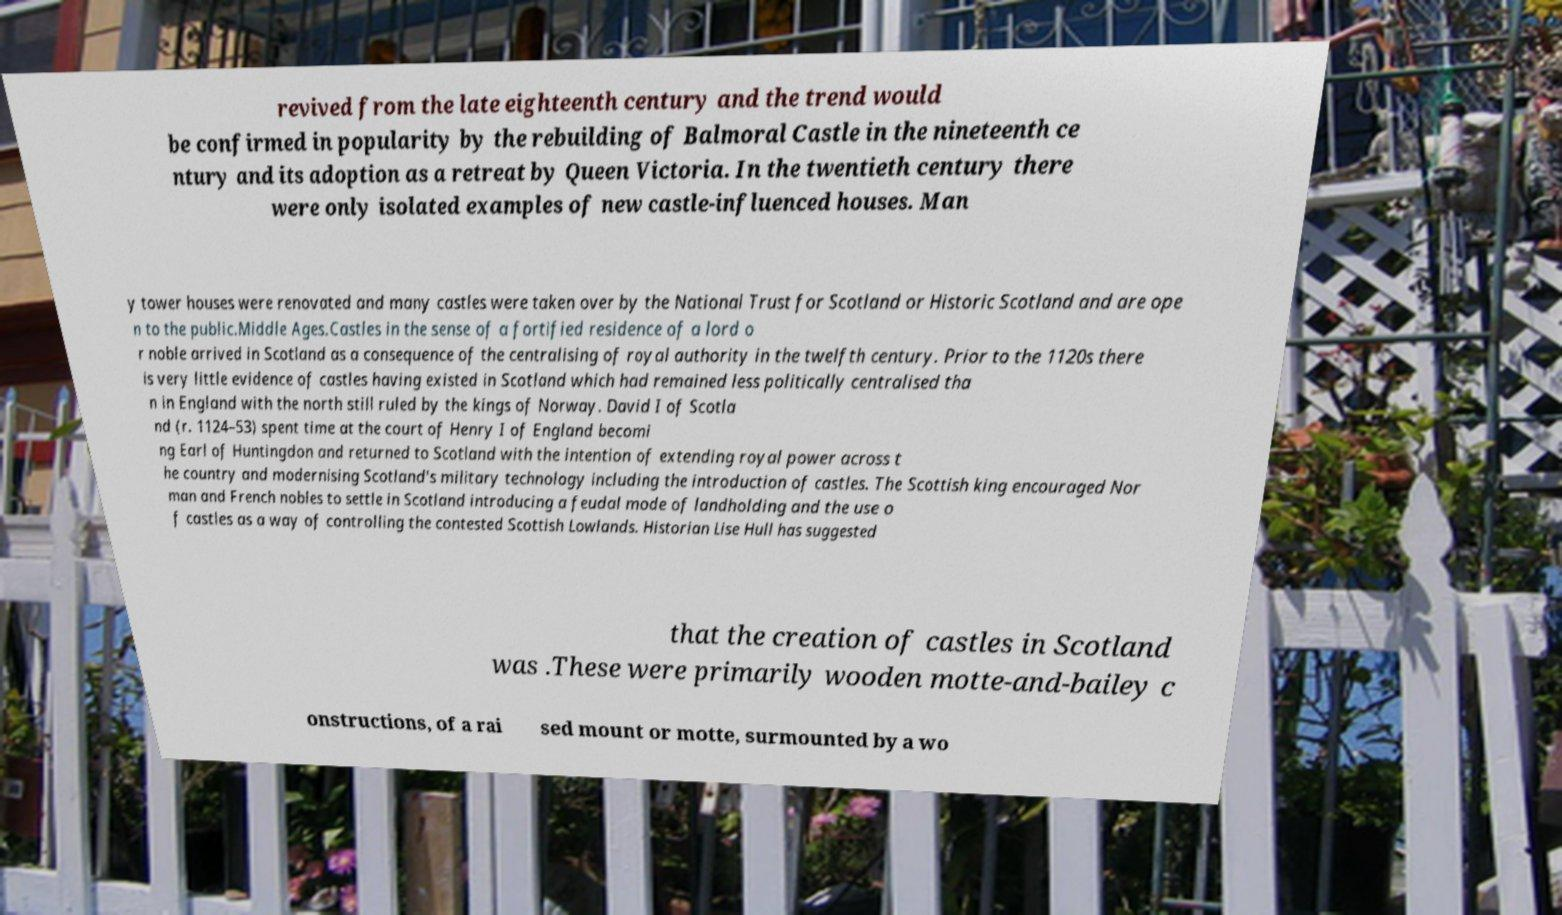I need the written content from this picture converted into text. Can you do that? revived from the late eighteenth century and the trend would be confirmed in popularity by the rebuilding of Balmoral Castle in the nineteenth ce ntury and its adoption as a retreat by Queen Victoria. In the twentieth century there were only isolated examples of new castle-influenced houses. Man y tower houses were renovated and many castles were taken over by the National Trust for Scotland or Historic Scotland and are ope n to the public.Middle Ages.Castles in the sense of a fortified residence of a lord o r noble arrived in Scotland as a consequence of the centralising of royal authority in the twelfth century. Prior to the 1120s there is very little evidence of castles having existed in Scotland which had remained less politically centralised tha n in England with the north still ruled by the kings of Norway. David I of Scotla nd (r. 1124–53) spent time at the court of Henry I of England becomi ng Earl of Huntingdon and returned to Scotland with the intention of extending royal power across t he country and modernising Scotland's military technology including the introduction of castles. The Scottish king encouraged Nor man and French nobles to settle in Scotland introducing a feudal mode of landholding and the use o f castles as a way of controlling the contested Scottish Lowlands. Historian Lise Hull has suggested that the creation of castles in Scotland was .These were primarily wooden motte-and-bailey c onstructions, of a rai sed mount or motte, surmounted by a wo 